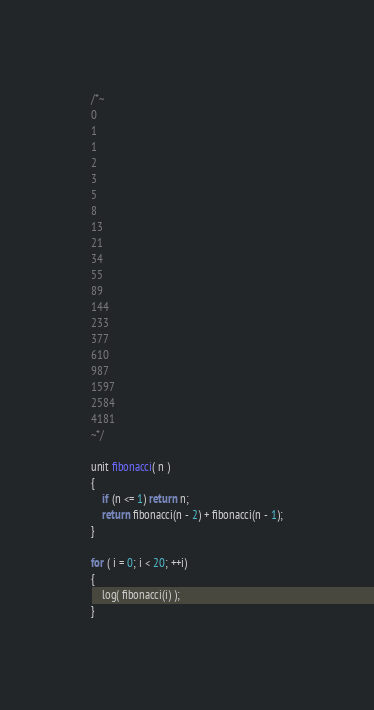<code> <loc_0><loc_0><loc_500><loc_500><_C_>/*~
0
1
1
2
3
5
8
13
21
34
55
89
144
233
377
610
987
1597
2584
4181
~*/

unit fibonacci( n )
{
	if (n <= 1) return n;
	return fibonacci(n - 2) + fibonacci(n - 1);
}

for ( i = 0; i < 20; ++i)
{
	log( fibonacci(i) );
}
</code> 